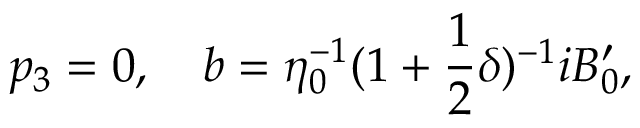Convert formula to latex. <formula><loc_0><loc_0><loc_500><loc_500>p _ { 3 } = 0 , \quad b = \eta _ { 0 } ^ { - 1 } ( 1 + \frac { 1 } { 2 } \delta ) ^ { - 1 } i B _ { 0 } ^ { \prime } ,</formula> 